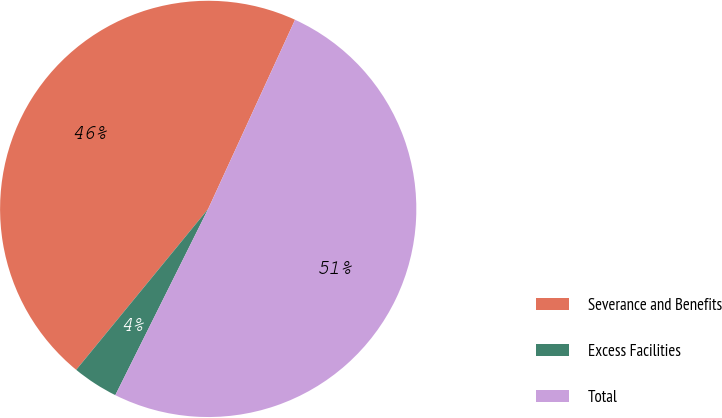<chart> <loc_0><loc_0><loc_500><loc_500><pie_chart><fcel>Severance and Benefits<fcel>Excess Facilities<fcel>Total<nl><fcel>45.92%<fcel>3.57%<fcel>50.51%<nl></chart> 